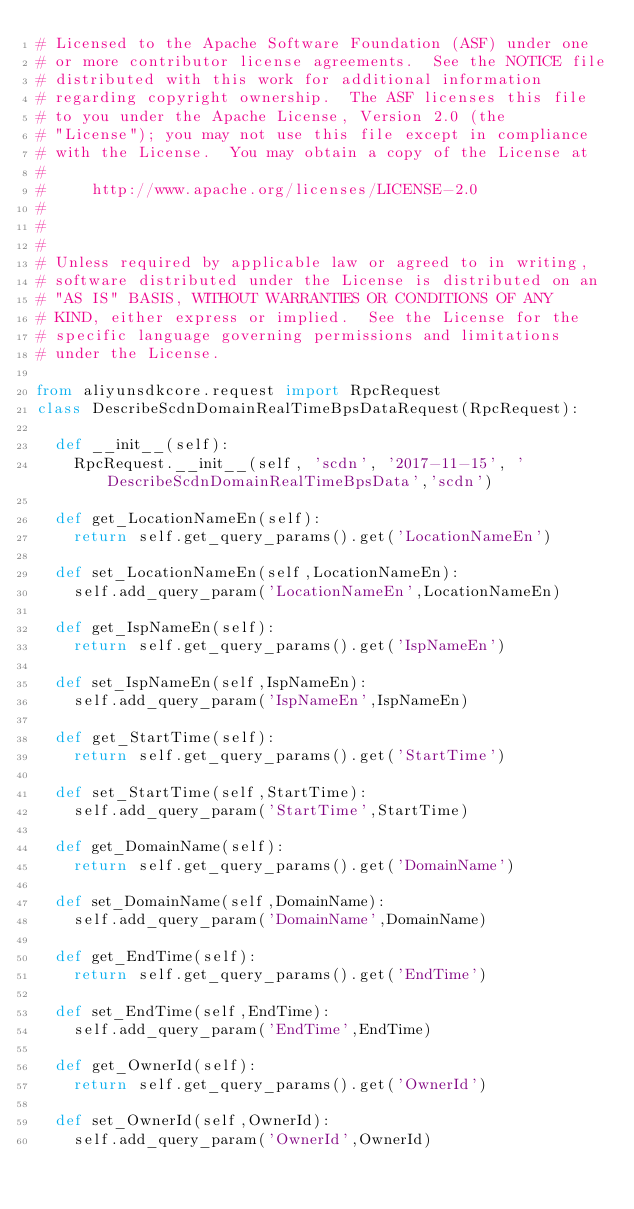<code> <loc_0><loc_0><loc_500><loc_500><_Python_># Licensed to the Apache Software Foundation (ASF) under one
# or more contributor license agreements.  See the NOTICE file
# distributed with this work for additional information
# regarding copyright ownership.  The ASF licenses this file
# to you under the Apache License, Version 2.0 (the
# "License"); you may not use this file except in compliance
# with the License.  You may obtain a copy of the License at
#
#     http://www.apache.org/licenses/LICENSE-2.0
#
#
#
# Unless required by applicable law or agreed to in writing,
# software distributed under the License is distributed on an
# "AS IS" BASIS, WITHOUT WARRANTIES OR CONDITIONS OF ANY
# KIND, either express or implied.  See the License for the
# specific language governing permissions and limitations
# under the License.

from aliyunsdkcore.request import RpcRequest
class DescribeScdnDomainRealTimeBpsDataRequest(RpcRequest):

	def __init__(self):
		RpcRequest.__init__(self, 'scdn', '2017-11-15', 'DescribeScdnDomainRealTimeBpsData','scdn')

	def get_LocationNameEn(self):
		return self.get_query_params().get('LocationNameEn')

	def set_LocationNameEn(self,LocationNameEn):
		self.add_query_param('LocationNameEn',LocationNameEn)

	def get_IspNameEn(self):
		return self.get_query_params().get('IspNameEn')

	def set_IspNameEn(self,IspNameEn):
		self.add_query_param('IspNameEn',IspNameEn)

	def get_StartTime(self):
		return self.get_query_params().get('StartTime')

	def set_StartTime(self,StartTime):
		self.add_query_param('StartTime',StartTime)

	def get_DomainName(self):
		return self.get_query_params().get('DomainName')

	def set_DomainName(self,DomainName):
		self.add_query_param('DomainName',DomainName)

	def get_EndTime(self):
		return self.get_query_params().get('EndTime')

	def set_EndTime(self,EndTime):
		self.add_query_param('EndTime',EndTime)

	def get_OwnerId(self):
		return self.get_query_params().get('OwnerId')

	def set_OwnerId(self,OwnerId):
		self.add_query_param('OwnerId',OwnerId)</code> 